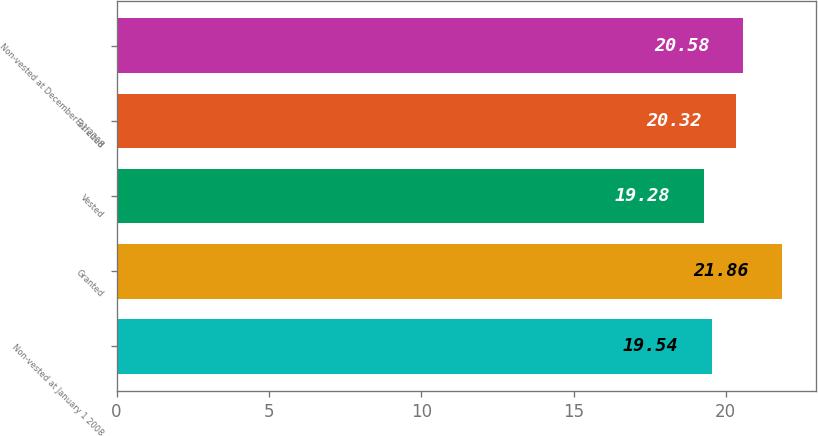<chart> <loc_0><loc_0><loc_500><loc_500><bar_chart><fcel>Non-vested at January 1 2008<fcel>Granted<fcel>Vested<fcel>Forfeited<fcel>Non-vested at December 31 2008<nl><fcel>19.54<fcel>21.86<fcel>19.28<fcel>20.32<fcel>20.58<nl></chart> 